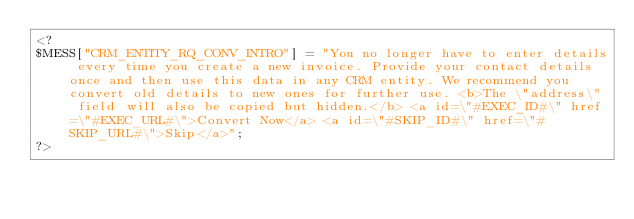Convert code to text. <code><loc_0><loc_0><loc_500><loc_500><_PHP_><?
$MESS["CRM_ENTITY_RQ_CONV_INTRO"] = "You no longer have to enter details every time you create a new invoice. Provide your contact details once and then use this data in any CRM entity. We recommend you convert old details to new ones for further use. <b>The \"address\" field will also be copied but hidden.</b> <a id=\"#EXEC_ID#\" href=\"#EXEC_URL#\">Convert Now</a> <a id=\"#SKIP_ID#\" href=\"#SKIP_URL#\">Skip</a>";
?></code> 